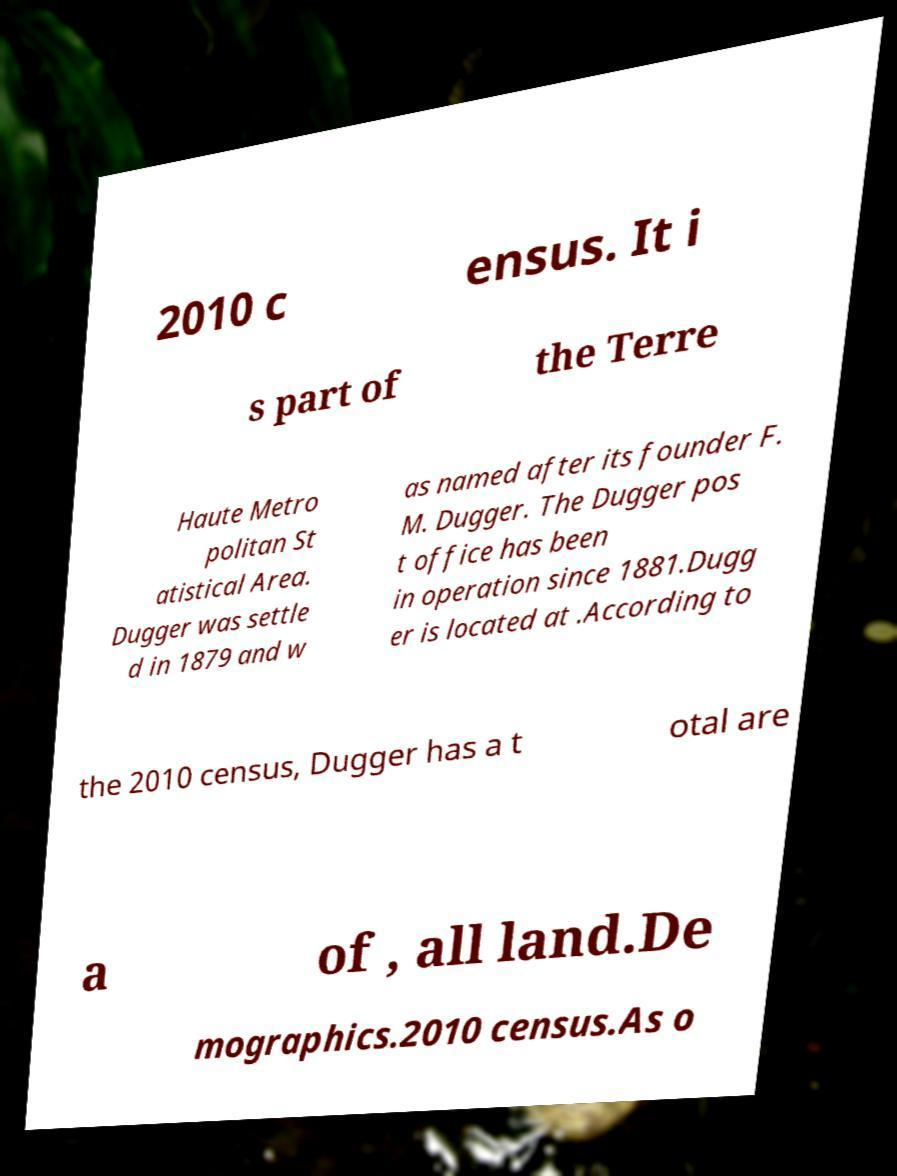What messages or text are displayed in this image? I need them in a readable, typed format. 2010 c ensus. It i s part of the Terre Haute Metro politan St atistical Area. Dugger was settle d in 1879 and w as named after its founder F. M. Dugger. The Dugger pos t office has been in operation since 1881.Dugg er is located at .According to the 2010 census, Dugger has a t otal are a of , all land.De mographics.2010 census.As o 